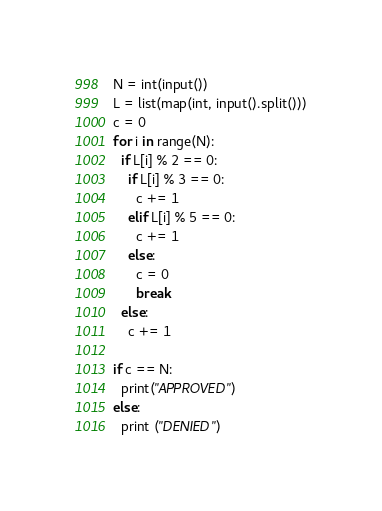Convert code to text. <code><loc_0><loc_0><loc_500><loc_500><_Python_>N = int(input())
L = list(map(int, input().split()))
c = 0
for i in range(N):
  if L[i] % 2 == 0:
    if L[i] % 3 == 0:
      c += 1
    elif L[i] % 5 == 0:
      c += 1
    else:
      c = 0
      break
  else:
    c += 1

if c == N:
  print("APPROVED")  
else:
  print ("DENIED")</code> 